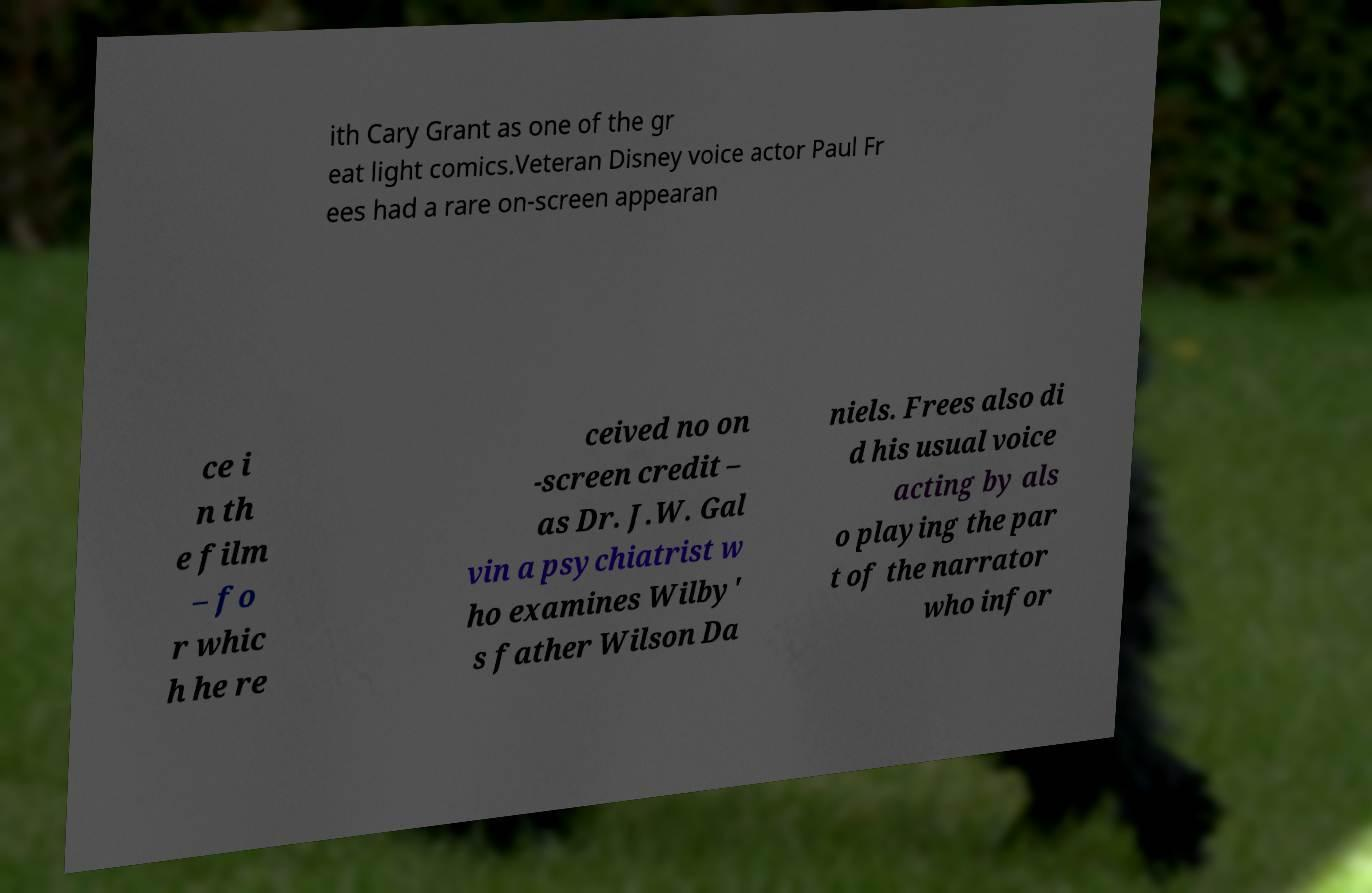Could you extract and type out the text from this image? ith Cary Grant as one of the gr eat light comics.Veteran Disney voice actor Paul Fr ees had a rare on-screen appearan ce i n th e film – fo r whic h he re ceived no on -screen credit – as Dr. J.W. Gal vin a psychiatrist w ho examines Wilby' s father Wilson Da niels. Frees also di d his usual voice acting by als o playing the par t of the narrator who infor 